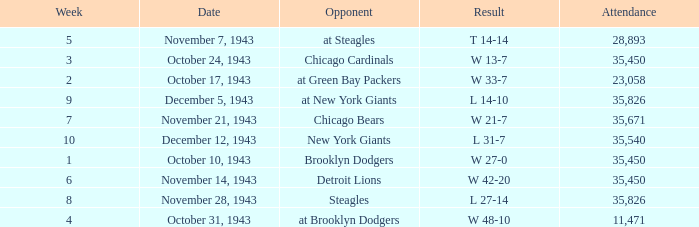What is the lowest attendance that has a week less than 4, and w 13-7 as the result? 35450.0. 